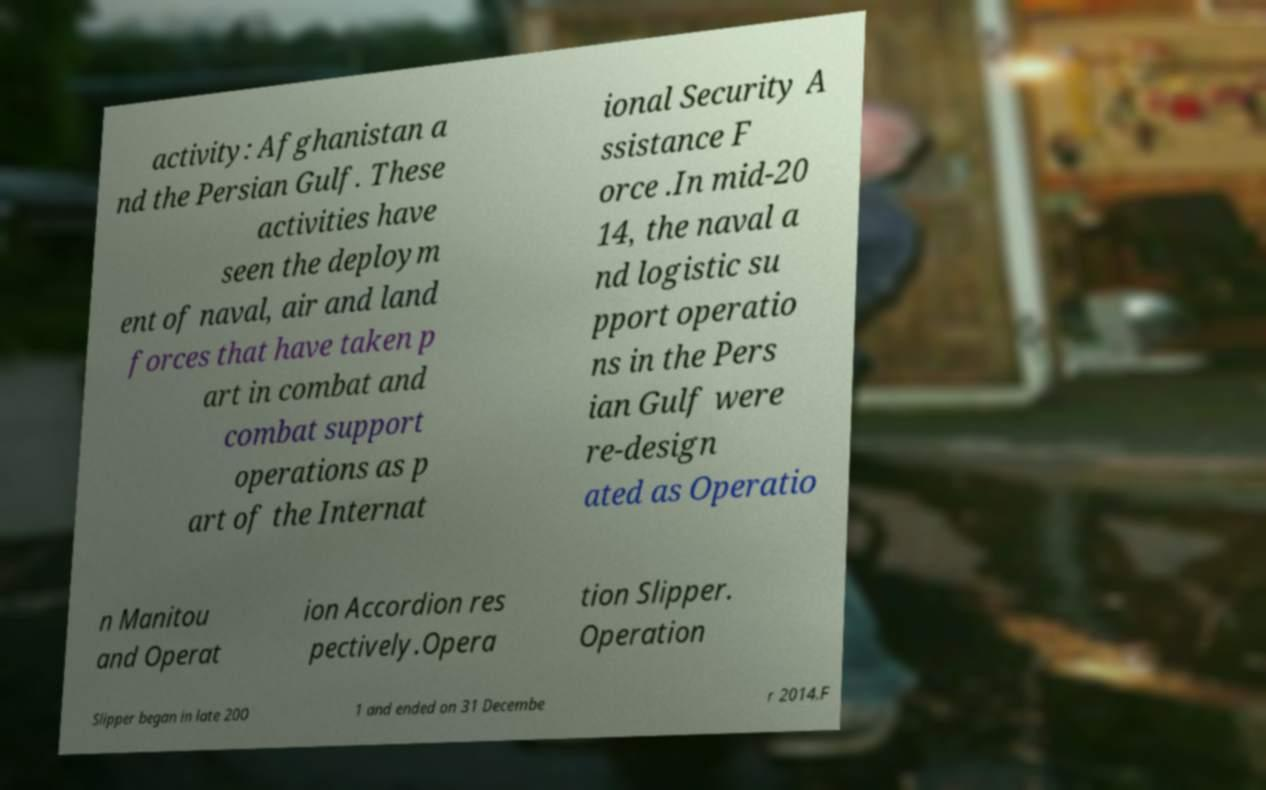Could you assist in decoding the text presented in this image and type it out clearly? activity: Afghanistan a nd the Persian Gulf. These activities have seen the deploym ent of naval, air and land forces that have taken p art in combat and combat support operations as p art of the Internat ional Security A ssistance F orce .In mid-20 14, the naval a nd logistic su pport operatio ns in the Pers ian Gulf were re-design ated as Operatio n Manitou and Operat ion Accordion res pectively.Opera tion Slipper. Operation Slipper began in late 200 1 and ended on 31 Decembe r 2014.F 